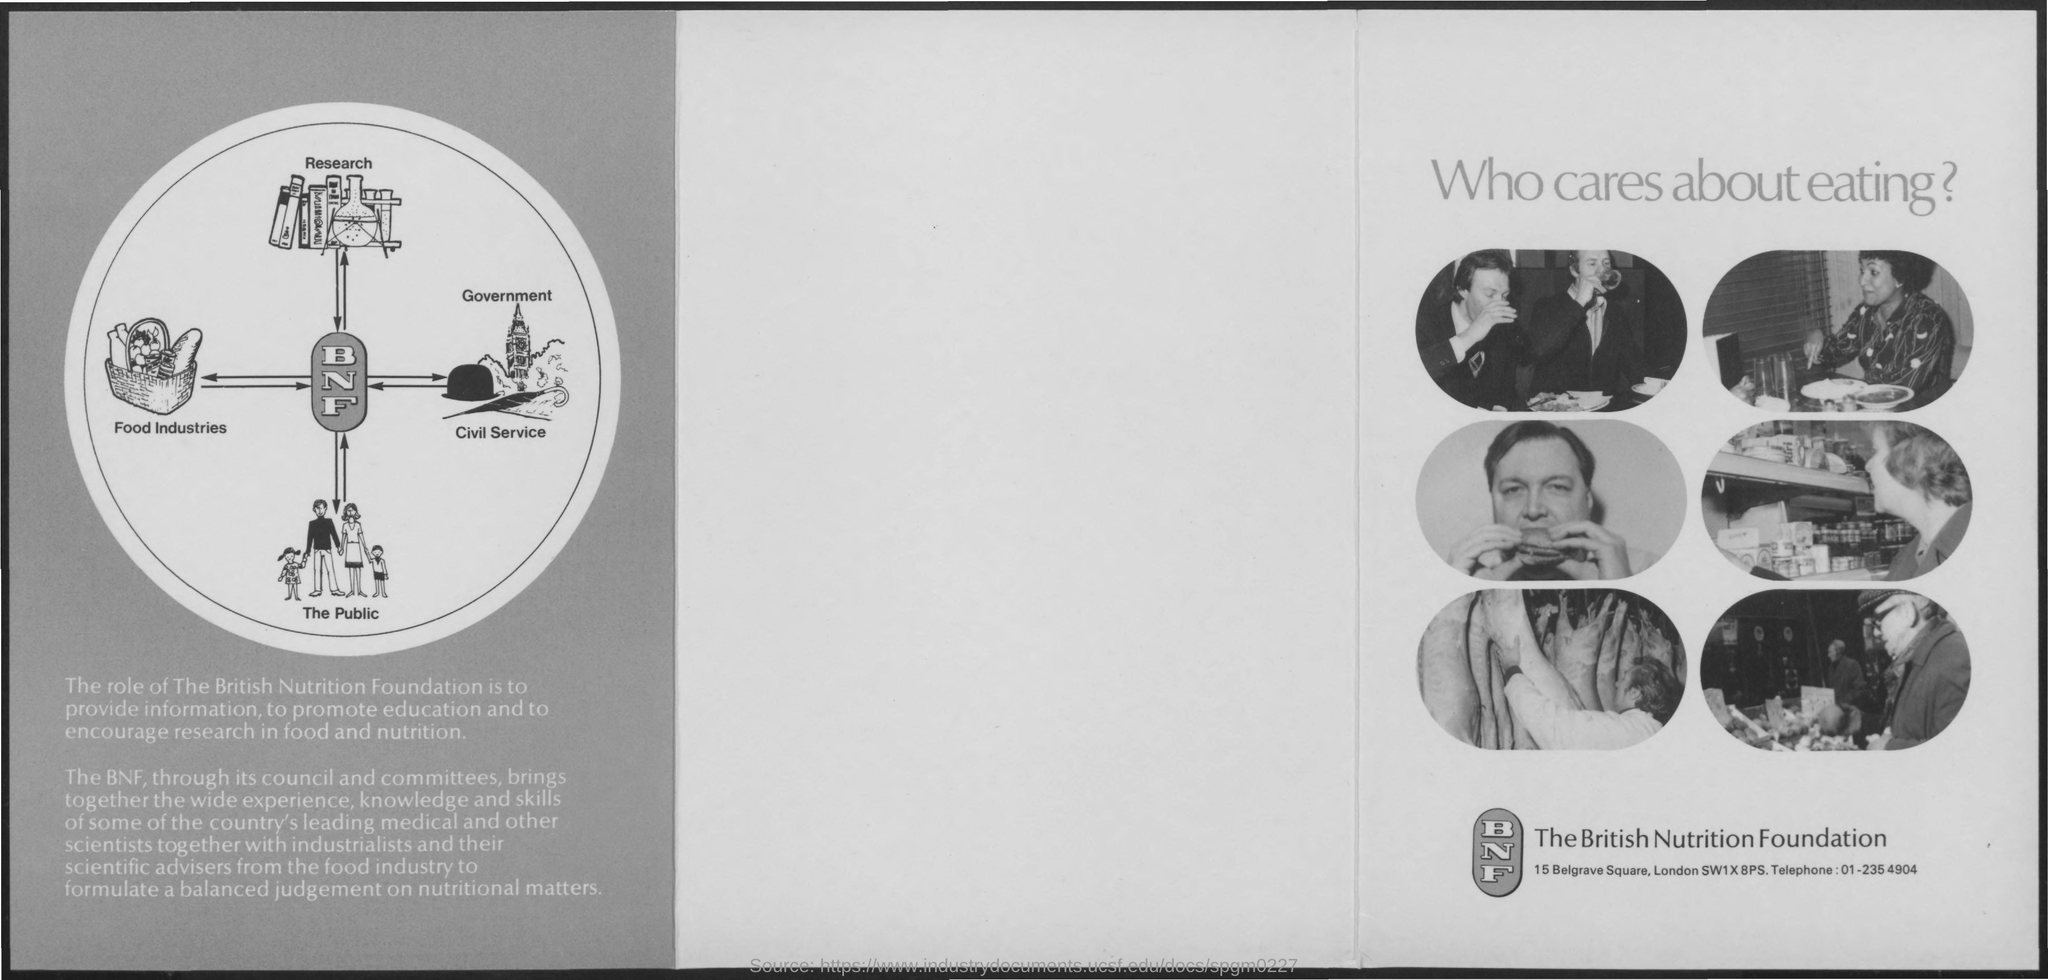Point out several critical features in this image. The British Nutrition Foundation brings together a diverse range of expertise to provide authoritative guidance on nutrition. The telephone number for the British Nutrition Foundation is 01-235 4904. 